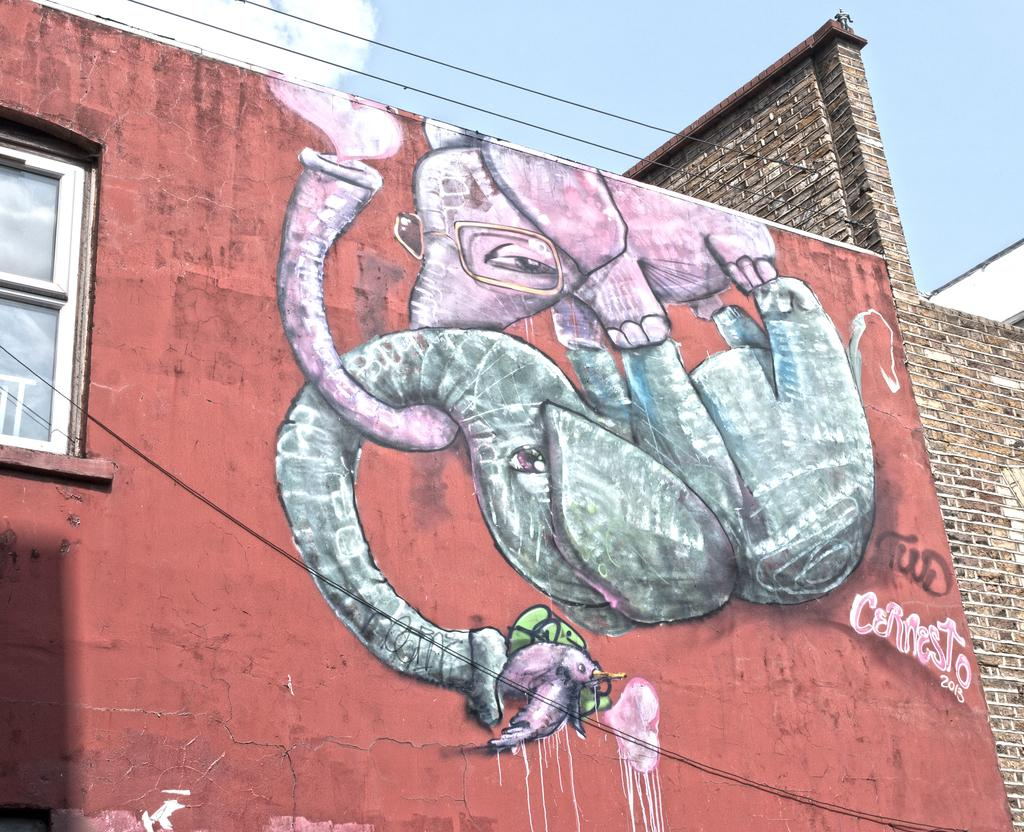What type of structure is present in the image? There is a building in the image. What feature can be seen on the building? The building has windows. What can be found on a wall inside the building? There is a painting on a wall in the image. What else is visible in the image besides the building? Wires and the sky are visible in the image. How would you describe the sky in the image? The sky appears to be cloudy in the image. Can you tell me how many muscles are visible on the kitty in the image? There is no kitty present in the image, so it is not possible to determine the number of muscles visible. 